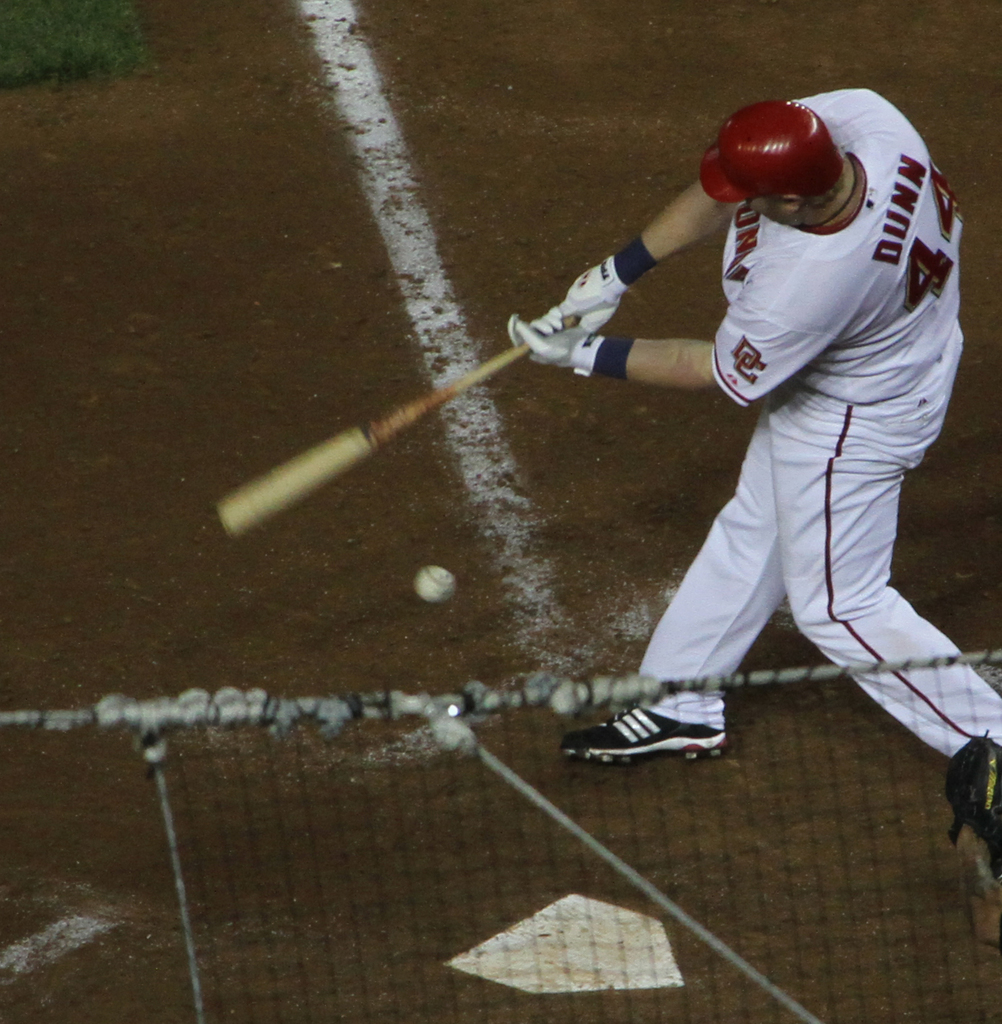Describe the atmosphere of the game as depicted in this image. The game takes place under powerful stadium lights that illuminate the field, highlighting the tense moment of a nighttime baseball game, with visible dirt kicked up from the player's swing. 